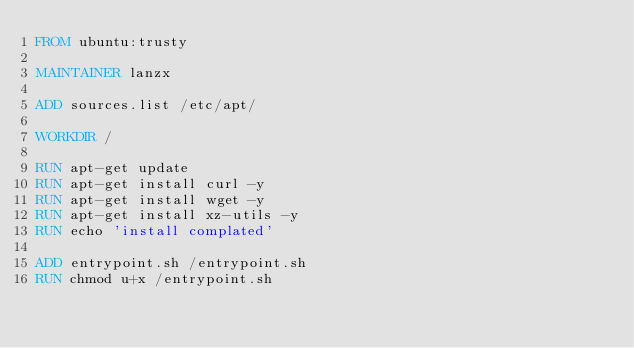Convert code to text. <code><loc_0><loc_0><loc_500><loc_500><_Dockerfile_>FROM ubuntu:trusty

MAINTAINER lanzx

ADD sources.list /etc/apt/

WORKDIR /

RUN apt-get update 
RUN apt-get install curl -y
RUN apt-get install wget -y 
RUN apt-get install xz-utils -y 
RUN echo 'install complated'

ADD entrypoint.sh /entrypoint.sh
RUN chmod u+x /entrypoint.sh
</code> 